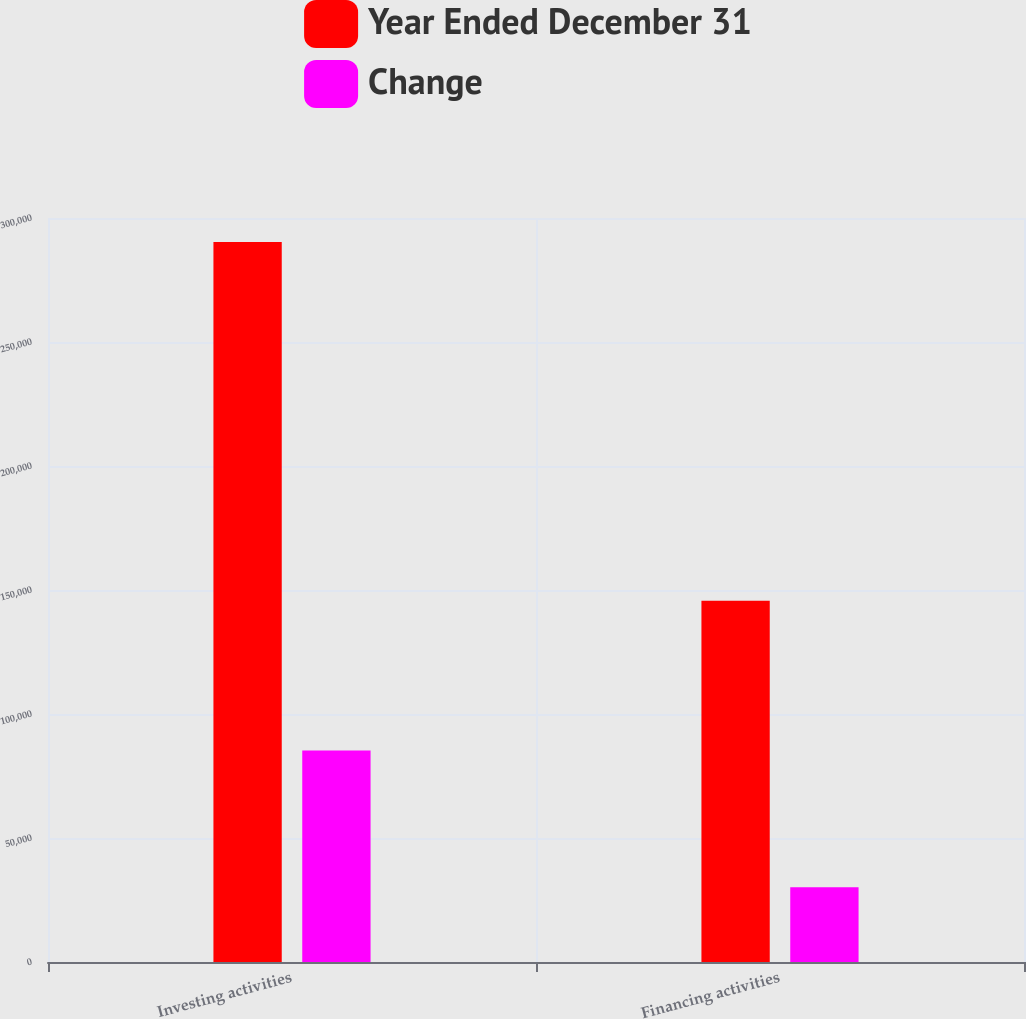Convert chart. <chart><loc_0><loc_0><loc_500><loc_500><stacked_bar_chart><ecel><fcel>Investing activities<fcel>Financing activities<nl><fcel>Year Ended December 31<fcel>290346<fcel>145665<nl><fcel>Change<fcel>85295<fcel>30123<nl></chart> 